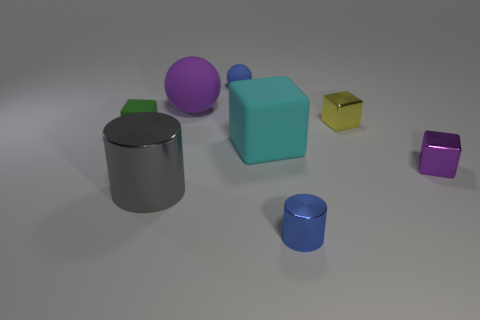Add 1 tiny matte cubes. How many objects exist? 9 Subtract all cylinders. How many objects are left? 6 Add 1 big purple rubber balls. How many big purple rubber balls are left? 2 Add 2 large shiny objects. How many large shiny objects exist? 3 Subtract 0 cyan spheres. How many objects are left? 8 Subtract all cylinders. Subtract all purple shiny things. How many objects are left? 5 